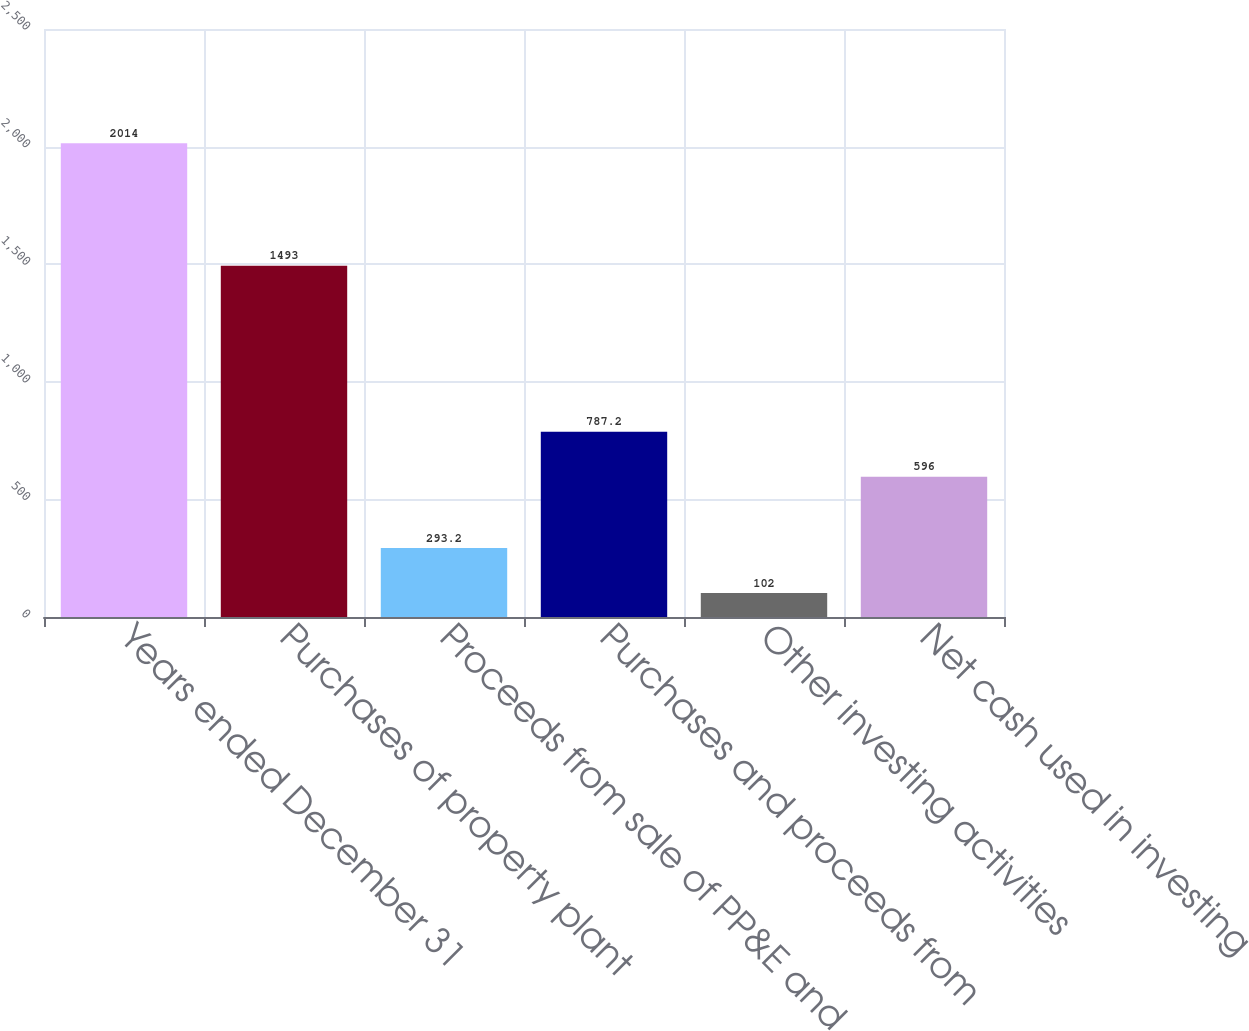Convert chart to OTSL. <chart><loc_0><loc_0><loc_500><loc_500><bar_chart><fcel>Years ended December 31<fcel>Purchases of property plant<fcel>Proceeds from sale of PP&E and<fcel>Purchases and proceeds from<fcel>Other investing activities<fcel>Net cash used in investing<nl><fcel>2014<fcel>1493<fcel>293.2<fcel>787.2<fcel>102<fcel>596<nl></chart> 